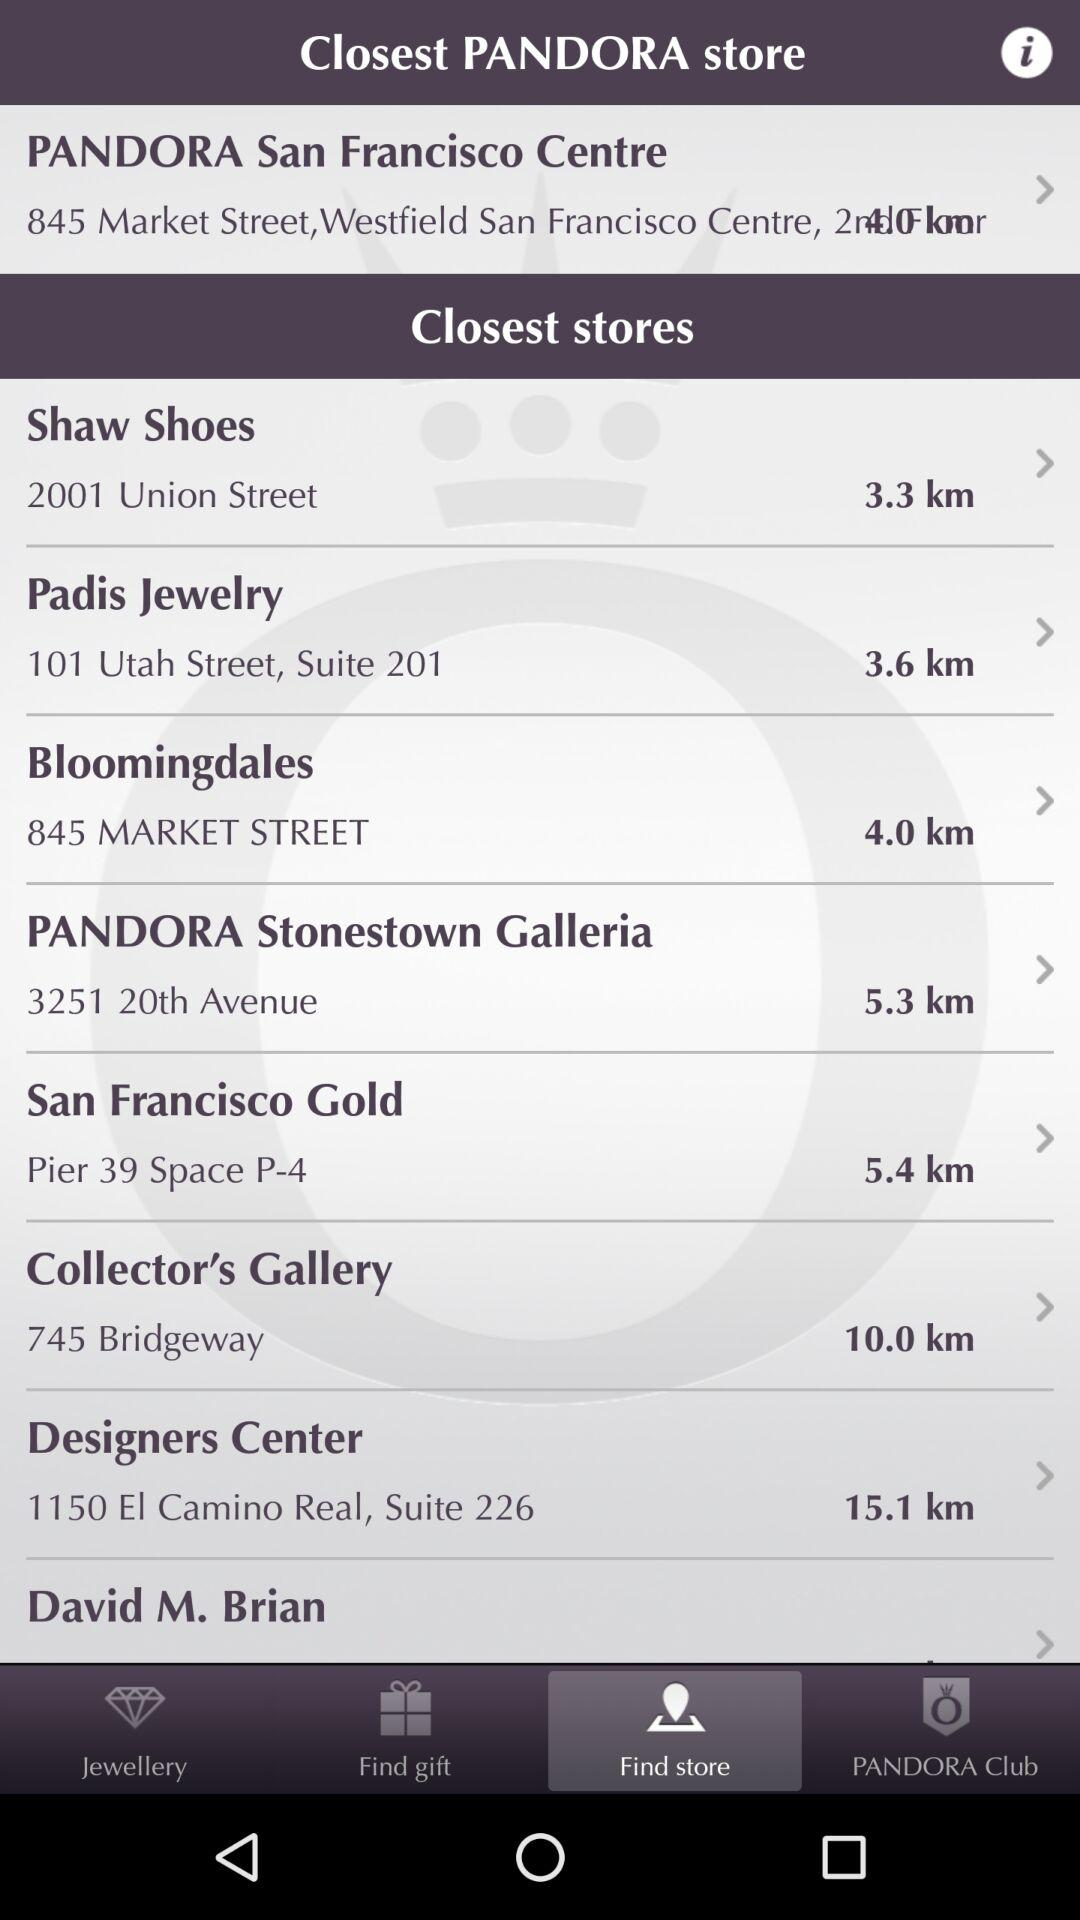How far is it from Padis Jewelry Store? It is 3.6 kilometers away. 